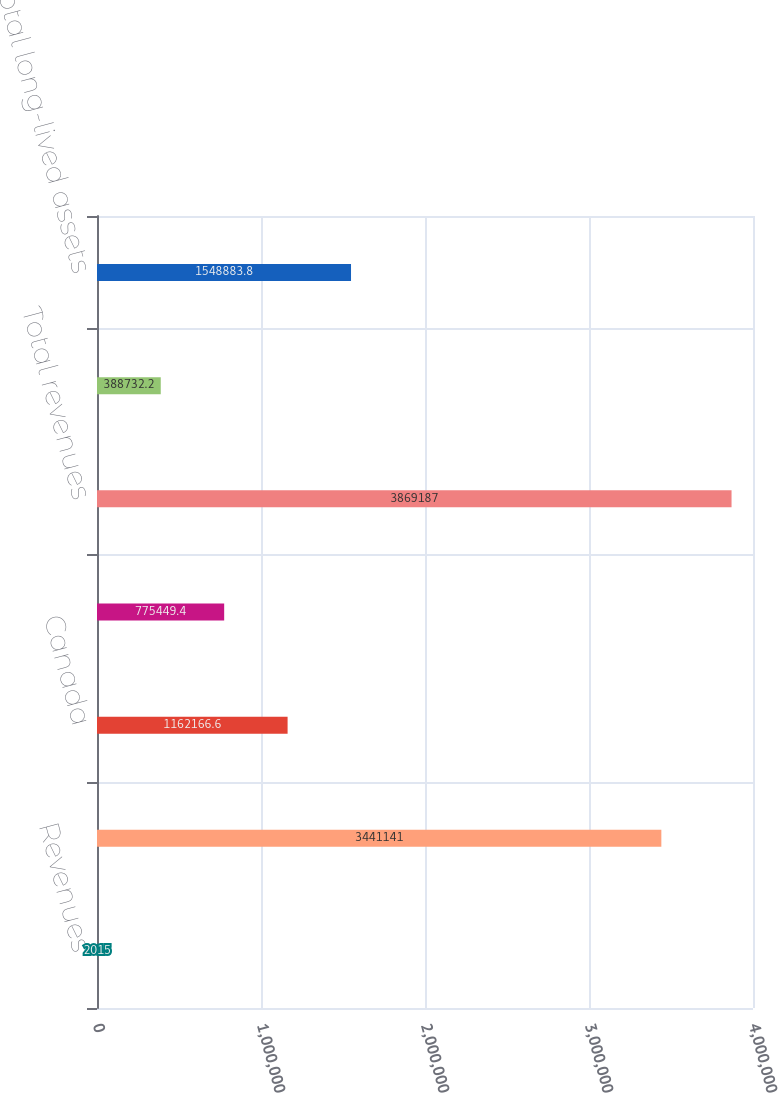Convert chart. <chart><loc_0><loc_0><loc_500><loc_500><bar_chart><fcel>Revenues<fcel>United States<fcel>Canada<fcel>Other foreign countries<fcel>Total revenues<fcel>Long-Lived Assets<fcel>Total long-lived assets<nl><fcel>2015<fcel>3.44114e+06<fcel>1.16217e+06<fcel>775449<fcel>3.86919e+06<fcel>388732<fcel>1.54888e+06<nl></chart> 